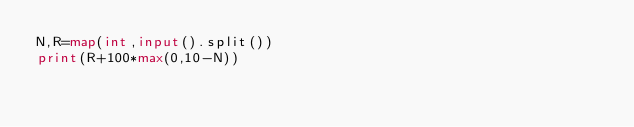<code> <loc_0><loc_0><loc_500><loc_500><_Python_>N,R=map(int,input().split())
print(R+100*max(0,10-N))</code> 